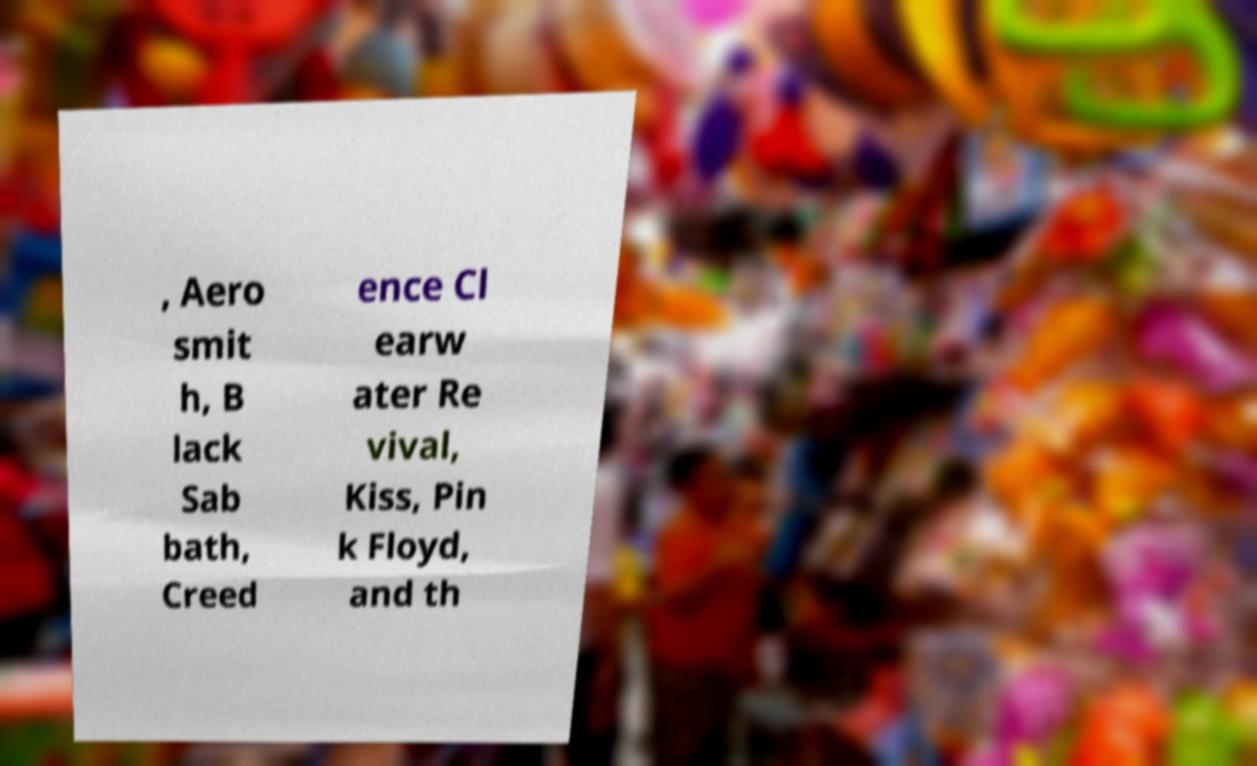Could you assist in decoding the text presented in this image and type it out clearly? , Aero smit h, B lack Sab bath, Creed ence Cl earw ater Re vival, Kiss, Pin k Floyd, and th 